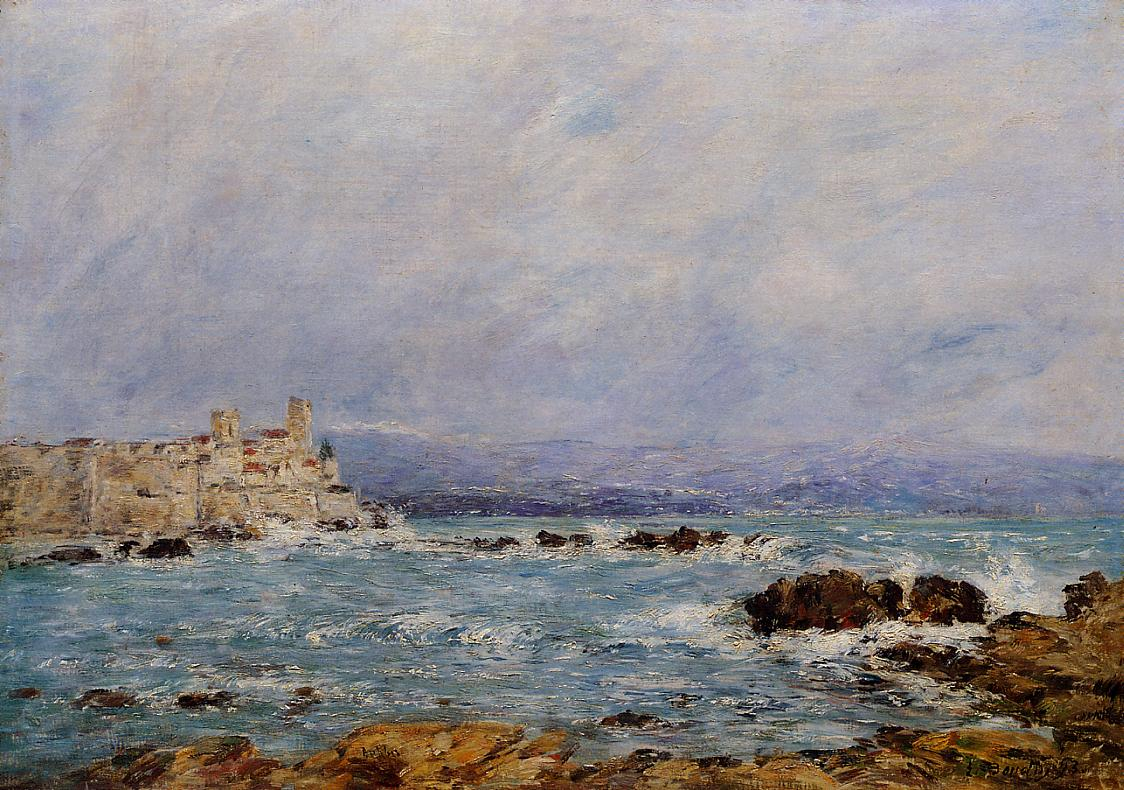If this painting were to come to life, how would the scene evolve? If this painting were to come to life, the scene would be dynamic and ever-changing. The waves would crash energetically against the rocks, creating a soothing yet powerful soundtrack of the sea. The castle on the cliff would reveal its bustling life; banners fluttering in the wind, distant sounds of people. Birds might soar gracefully above, while the sun would cast shifting shadows, enhancing the serene beauty. A gentle breeze would carry the scent of salt and seaweed, enveloping viewers in a sensory-rich experience that perfectly captures the essence of the impressionist masterpiece. 